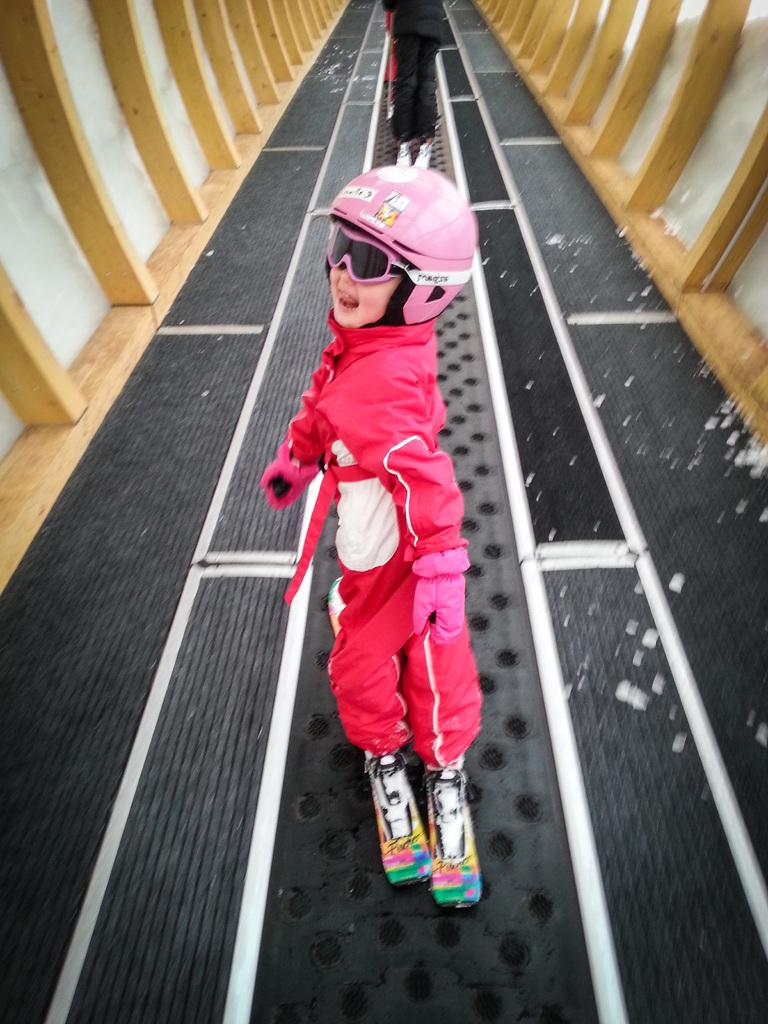How many people are in the image? There are two people in the image. What are the people doing in the image? The people are skating. What can be observed about the environment where the skating is taking place? The skating is taking place between wooden walls. What color are the pieces on the floor? The pieces on the floor are white. What type of juice is being served to the crow in the image? There is no crow or juice present in the image. 